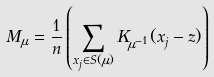<formula> <loc_0><loc_0><loc_500><loc_500>M _ { \mu } = \frac { 1 } { n } \left ( \sum _ { x _ { j } \in S ( \mu ) } K _ { \mu ^ { - 1 } } ( x _ { j } - z ) \right )</formula> 